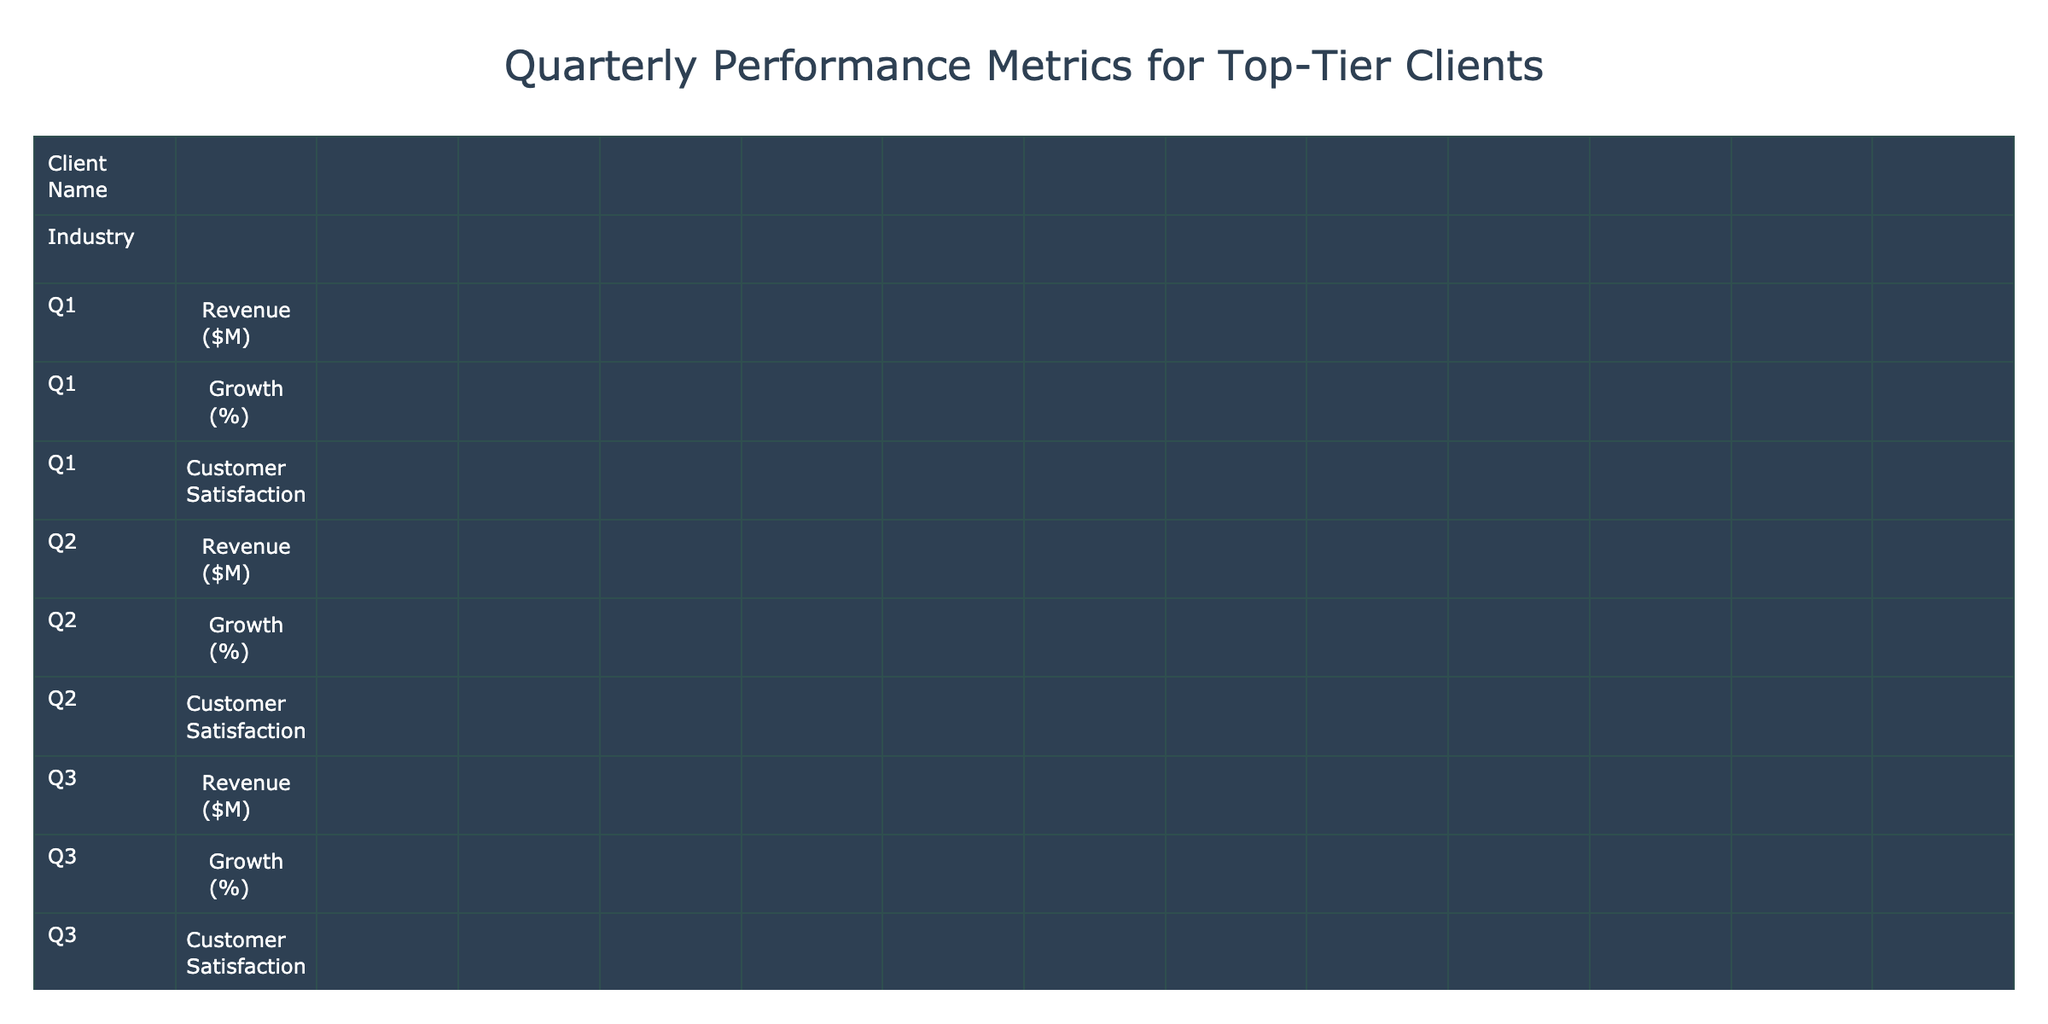What was the revenue of Amazon in Q4? According to the table, the revenue for Amazon in Q4 is listed as $149,204 million.
Answer: 149,204 Which client had the highest Q1 revenue? The highest Q1 revenue is shown for Walmart, at $141,569 million.
Answer: Walmart Did Johnson & Johnson experience growth in Q2? The growth percentage for Johnson & Johnson in Q2 is 2.5%, which indicates that there was an increase in revenue.
Answer: Yes What is the average customer satisfaction of the clients in Q3? To find the average customer satisfaction for Q3, we add up Q3 customer satisfaction ratings: (4.9 + 4.3 + 4.0 + 3.9 + 4.4 + 3.7 + 4.5 + 4.3 + 4.8 + 3.9) = 43.8. There are 10 clients, so the average is 43.8 / 10 = 4.38.
Answer: 4.38 Which industry did Goldman Sachs belong to? Goldman Sachs is categorized under the Finance industry according to the table.
Answer: Finance What was the overall growth percentage for Pfizer from Q1 to Q4? To calculate the overall growth percentage for Pfizer, we compare the Q1 revenue ($25,661 million) to the Q4 revenue ($24,290 million). The growth is calculated as ((24,290 - 25,661) / 25,661) * 100 = -5.35%.
Answer: -5.35% Which client had the biggest decrease in customer satisfaction from Q1 to Q4? Counting the customer satisfaction ratings from Q1 to Q4, Goldman Sachs shows a decrease from 4.2 in Q1 to 4.0 in Q4, a drop of 0.2. This is the largest decrease among the listed clients.
Answer: Goldman Sachs What was the average revenue growth for all clients in Q2? First, we sum the Q2 growth percentages: (–2.1 + –8.3 + 8.0 + 36.1 + 2.5 + 19.2 + –1.2 + 3.0 + 4.1 + 8.1) = 68.4. Then we divide by the number of clients (10), which gives an average growth of 68.4 / 10 = 6.84%.
Answer: 6.84% Which client saw the highest growth percentage in Q3? By reviewing the Q3 growth percentages, we find that ExxonMobil had the highest at –3.1% among clients that reported a positive growth change which is 25.2% for Boeing.
Answer: Boeing Did any client have a revenue loss for the entire year? Analyzing the revenues from Q1 to Q4 for each client, we see that ExxonMobil dropped from $84,972 million in Q1 to $95,429 in Q4, which indicates a revenue loss over the year.
Answer: Yes 